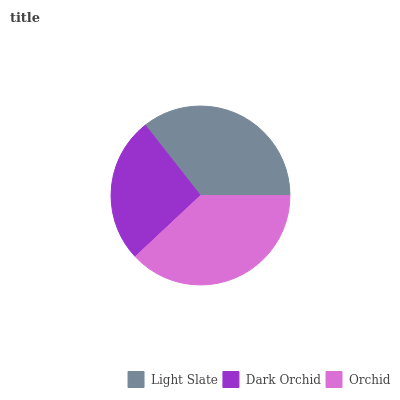Is Dark Orchid the minimum?
Answer yes or no. Yes. Is Orchid the maximum?
Answer yes or no. Yes. Is Orchid the minimum?
Answer yes or no. No. Is Dark Orchid the maximum?
Answer yes or no. No. Is Orchid greater than Dark Orchid?
Answer yes or no. Yes. Is Dark Orchid less than Orchid?
Answer yes or no. Yes. Is Dark Orchid greater than Orchid?
Answer yes or no. No. Is Orchid less than Dark Orchid?
Answer yes or no. No. Is Light Slate the high median?
Answer yes or no. Yes. Is Light Slate the low median?
Answer yes or no. Yes. Is Dark Orchid the high median?
Answer yes or no. No. Is Dark Orchid the low median?
Answer yes or no. No. 